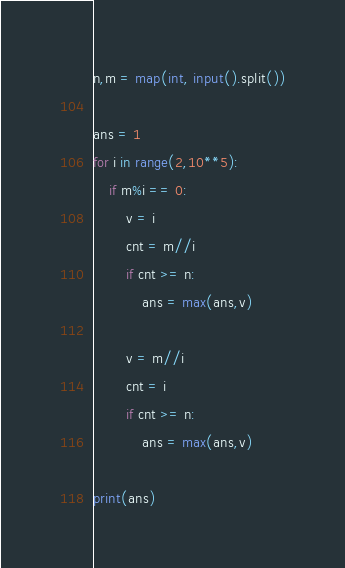<code> <loc_0><loc_0><loc_500><loc_500><_Python_>n,m = map(int, input().split())

ans = 1
for i in range(2,10**5):
    if m%i == 0:
        v = i
        cnt = m//i
        if cnt >= n:
            ans = max(ans,v)

        v = m//i
        cnt = i
        if cnt >= n:
            ans = max(ans,v)

print(ans)</code> 